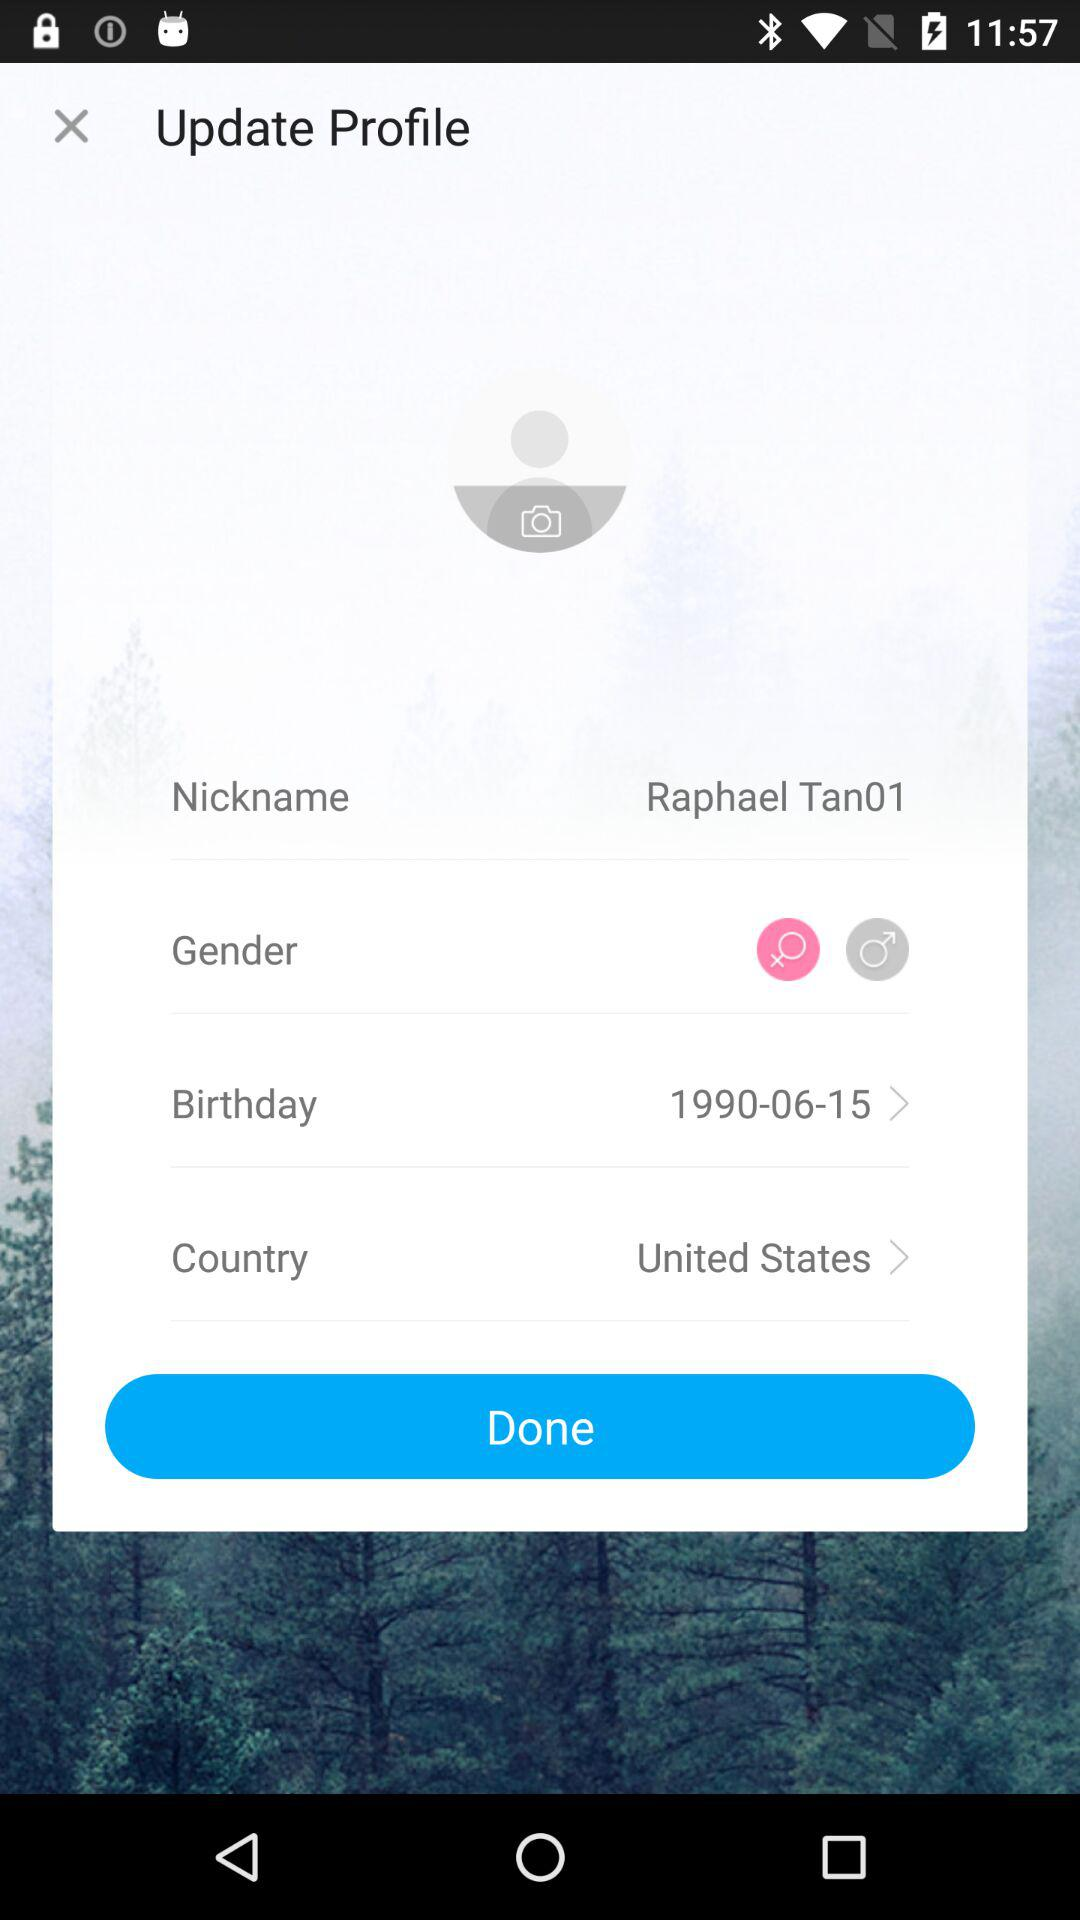What is the gender option? The gender options are "Female" and "Male". 